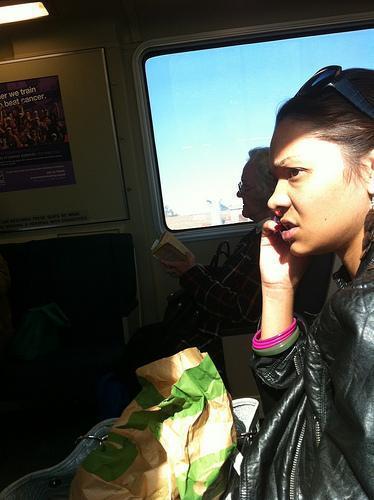How many people can be seen?
Give a very brief answer. 2. 